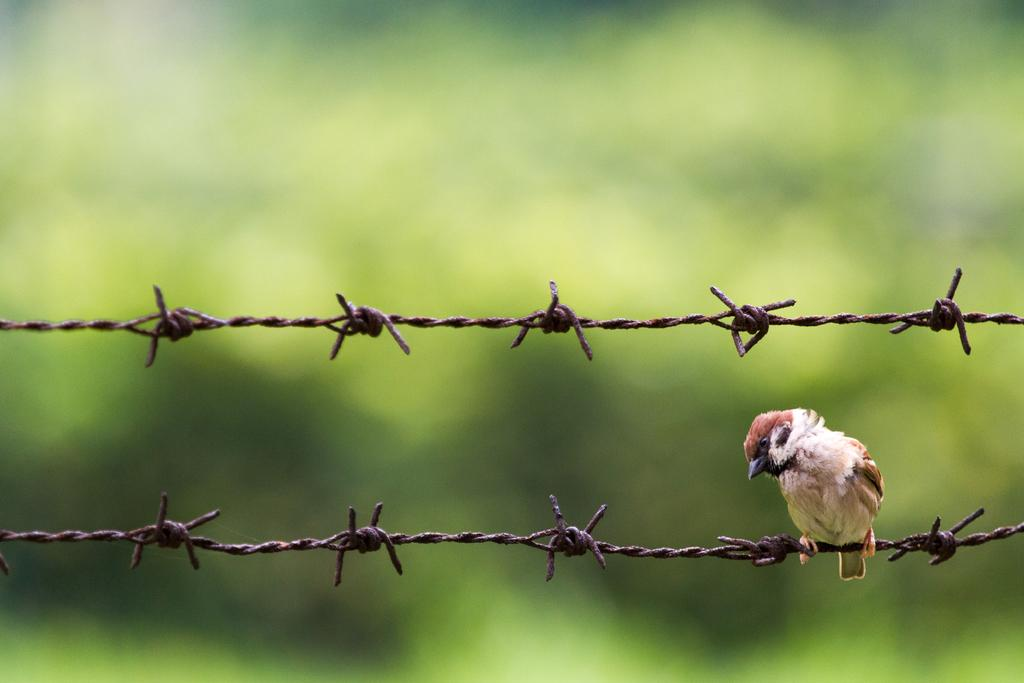What is present in the image that serves as a barrier or boundary? There is a fencing in the image. Is there any wildlife visible on the fencing? Yes, there is a bird on the fencing. How would you describe the background of the image? The background of the image is blurred. What type of hose is being used for the operation in the image? There is no hose or operation present in the image. How does the bird fall from the fencing in the image? The bird does not fall from the fencing in the image; it is perched on the fencing. 